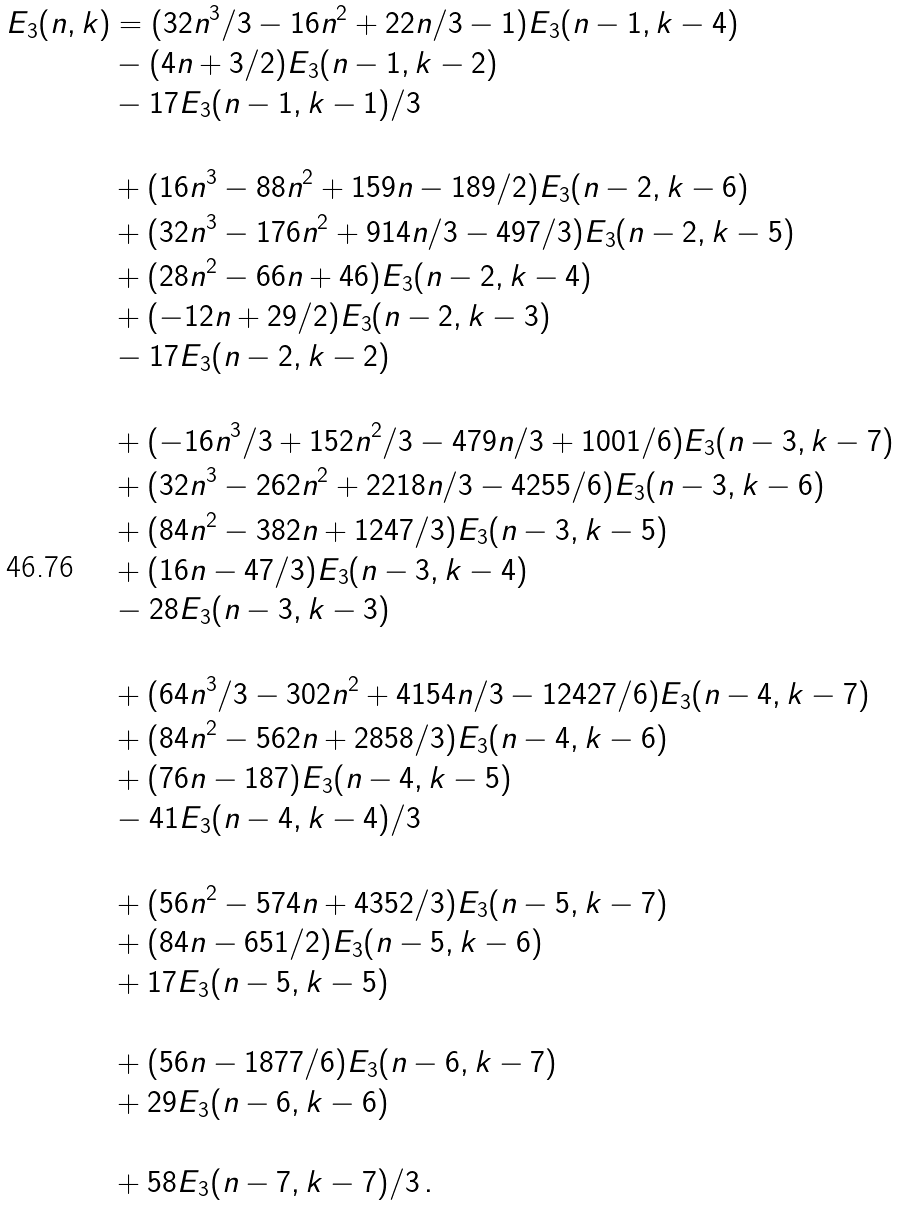Convert formula to latex. <formula><loc_0><loc_0><loc_500><loc_500>E _ { 3 } ( n , k ) & = ( 3 2 n ^ { 3 } / 3 - 1 6 n ^ { 2 } + 2 2 n / 3 - 1 ) E _ { 3 } ( n - 1 , k - 4 ) \\ & - ( 4 n + 3 / 2 ) E _ { 3 } ( n - 1 , k - 2 ) \\ & - 1 7 E _ { 3 } ( n - 1 , k - 1 ) / 3 \\ & \\ & + ( 1 6 n ^ { 3 } - 8 8 n ^ { 2 } + 1 5 9 n - 1 8 9 / 2 ) E _ { 3 } ( n - 2 , k - 6 ) \\ & + ( 3 2 n ^ { 3 } - 1 7 6 n ^ { 2 } + 9 1 4 n / 3 - 4 9 7 / 3 ) E _ { 3 } ( n - 2 , k - 5 ) \\ & + ( 2 8 n ^ { 2 } - 6 6 n + 4 6 ) E _ { 3 } ( n - 2 , k - 4 ) \\ & + ( - 1 2 n + 2 9 / 2 ) E _ { 3 } ( n - 2 , k - 3 ) \\ & - 1 7 E _ { 3 } ( n - 2 , k - 2 ) \\ & \\ & + ( - 1 6 n ^ { 3 } / 3 + 1 5 2 n ^ { 2 } / 3 - 4 7 9 n / 3 + 1 0 0 1 / 6 ) E _ { 3 } ( n - 3 , k - 7 ) \\ & + ( 3 2 n ^ { 3 } - 2 6 2 n ^ { 2 } + 2 2 1 8 n / 3 - 4 2 5 5 / 6 ) E _ { 3 } ( n - 3 , k - 6 ) \\ & + ( 8 4 n ^ { 2 } - 3 8 2 n + 1 2 4 7 / 3 ) E _ { 3 } ( n - 3 , k - 5 ) \\ & + ( 1 6 n - 4 7 / 3 ) E _ { 3 } ( n - 3 , k - 4 ) \\ & - 2 8 E _ { 3 } ( n - 3 , k - 3 ) \\ & \\ & + ( 6 4 n ^ { 3 } / 3 - 3 0 2 n ^ { 2 } + 4 1 5 4 n / 3 - 1 2 4 2 7 / 6 ) E _ { 3 } ( n - 4 , k - 7 ) \\ & + ( 8 4 n ^ { 2 } - 5 6 2 n + 2 8 5 8 / 3 ) E _ { 3 } ( n - 4 , k - 6 ) \\ & + ( 7 6 n - 1 8 7 ) E _ { 3 } ( n - 4 , k - 5 ) \\ & - 4 1 E _ { 3 } ( n - 4 , k - 4 ) / 3 \\ & \\ & + ( 5 6 n ^ { 2 } - 5 7 4 n + 4 3 5 2 / 3 ) E _ { 3 } ( n - 5 , k - 7 ) \\ & + ( 8 4 n - 6 5 1 / 2 ) E _ { 3 } ( n - 5 , k - 6 ) \\ & + 1 7 E _ { 3 } ( n - 5 , k - 5 ) \\ & \\ & + ( 5 6 n - 1 8 7 7 / 6 ) E _ { 3 } ( n - 6 , k - 7 ) \\ & + 2 9 E _ { 3 } ( n - 6 , k - 6 ) \\ & \\ & + 5 8 E _ { 3 } ( n - 7 , k - 7 ) / 3 \, .</formula> 